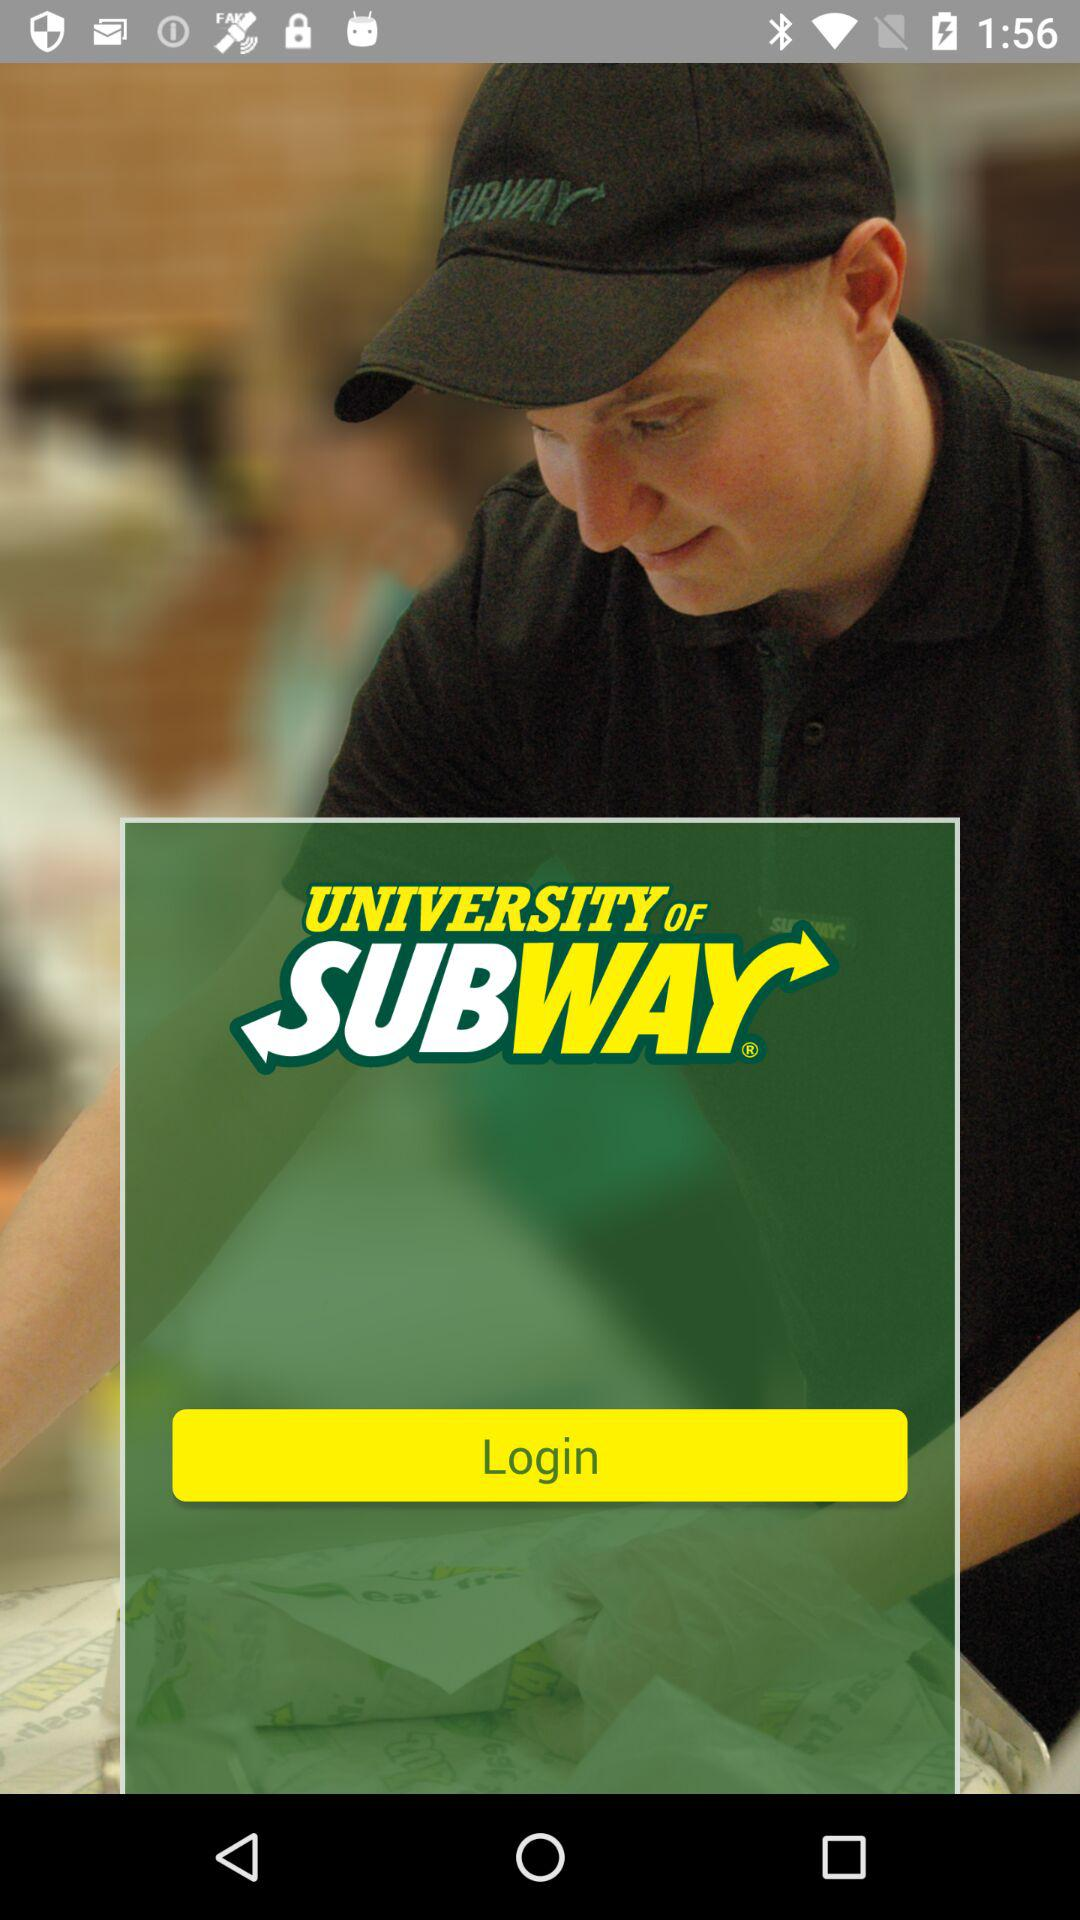What is the application name? The application name is "UNIVERSITY OF SUBWAY". 